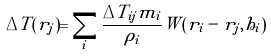Convert formula to latex. <formula><loc_0><loc_0><loc_500><loc_500>\Delta T ( r _ { j } ) = \sum _ { i } \frac { \Delta T _ { i j } m _ { i } } { \rho _ { i } } W ( r _ { i } - r _ { j } , h _ { i } )</formula> 